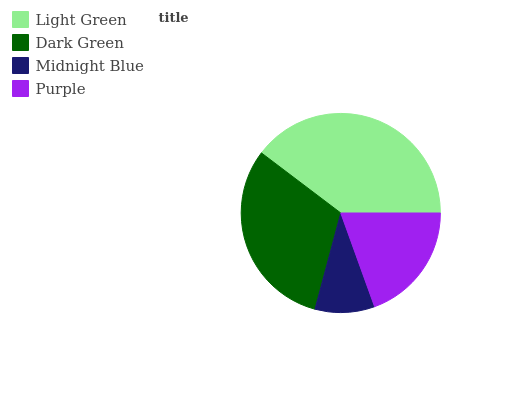Is Midnight Blue the minimum?
Answer yes or no. Yes. Is Light Green the maximum?
Answer yes or no. Yes. Is Dark Green the minimum?
Answer yes or no. No. Is Dark Green the maximum?
Answer yes or no. No. Is Light Green greater than Dark Green?
Answer yes or no. Yes. Is Dark Green less than Light Green?
Answer yes or no. Yes. Is Dark Green greater than Light Green?
Answer yes or no. No. Is Light Green less than Dark Green?
Answer yes or no. No. Is Dark Green the high median?
Answer yes or no. Yes. Is Purple the low median?
Answer yes or no. Yes. Is Purple the high median?
Answer yes or no. No. Is Dark Green the low median?
Answer yes or no. No. 